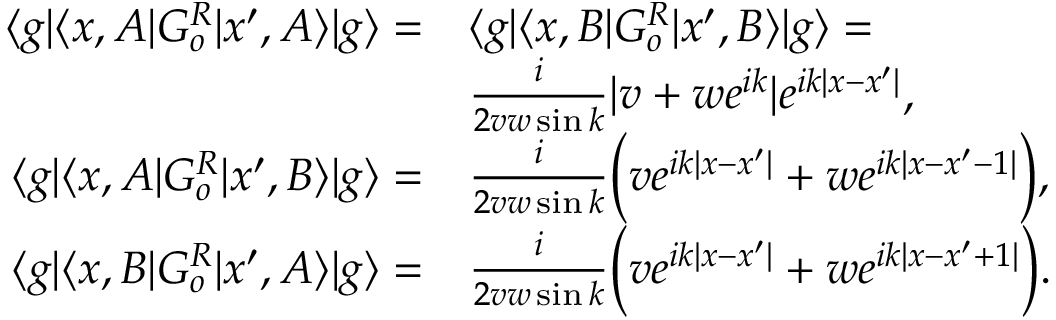Convert formula to latex. <formula><loc_0><loc_0><loc_500><loc_500>\begin{array} { r l } { \langle g | \langle x , A | G _ { o } ^ { R } | x ^ { \prime } , A \rangle | g \rangle = } & { \langle g | \langle x , B | G _ { o } ^ { R } | x ^ { \prime } , B \rangle | g \rangle = } \\ & { \frac { i } { 2 v w \sin { k } } | v + w e ^ { i k } | e ^ { i k | x - x ^ { \prime } | } , } \\ { \langle g | \langle x , A | G _ { o } ^ { R } | x ^ { \prime } , B \rangle | g \rangle = } & { \frac { i } { 2 v w \sin { k } } \left ( v e ^ { i k | x - x ^ { \prime } | } + w e ^ { i k | x - x ^ { \prime } - 1 | } \right ) , } \\ { \langle g | \langle x , B | G _ { o } ^ { R } | x ^ { \prime } , A \rangle | g \rangle = } & { \frac { i } { 2 v w \sin { k } } \left ( v e ^ { i k | x - x ^ { \prime } | } + w e ^ { i k | x - x ^ { \prime } + 1 | } \right ) . } \end{array}</formula> 